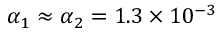Convert formula to latex. <formula><loc_0><loc_0><loc_500><loc_500>\alpha _ { 1 } \approx \alpha _ { 2 } = 1 . 3 \times 1 0 ^ { - 3 }</formula> 